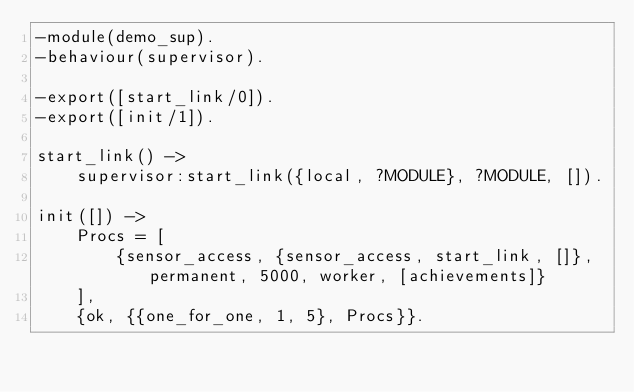Convert code to text. <code><loc_0><loc_0><loc_500><loc_500><_Erlang_>-module(demo_sup).
-behaviour(supervisor).

-export([start_link/0]).
-export([init/1]).

start_link() ->
	supervisor:start_link({local, ?MODULE}, ?MODULE, []).

init([]) ->
	Procs = [
        {sensor_access, {sensor_access, start_link, []}, permanent, 5000, worker, [achievements]}
    ],
	{ok, {{one_for_one, 1, 5}, Procs}}.
</code> 